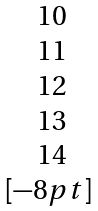Convert formula to latex. <formula><loc_0><loc_0><loc_500><loc_500>\begin{matrix} 1 0 \\ 1 1 \\ 1 2 \\ 1 3 \\ 1 4 \\ [ - 8 p t ] \ \end{matrix}</formula> 